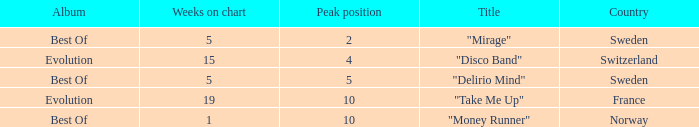What is the title of the single with the peak position of 10 and from France? "Take Me Up". 